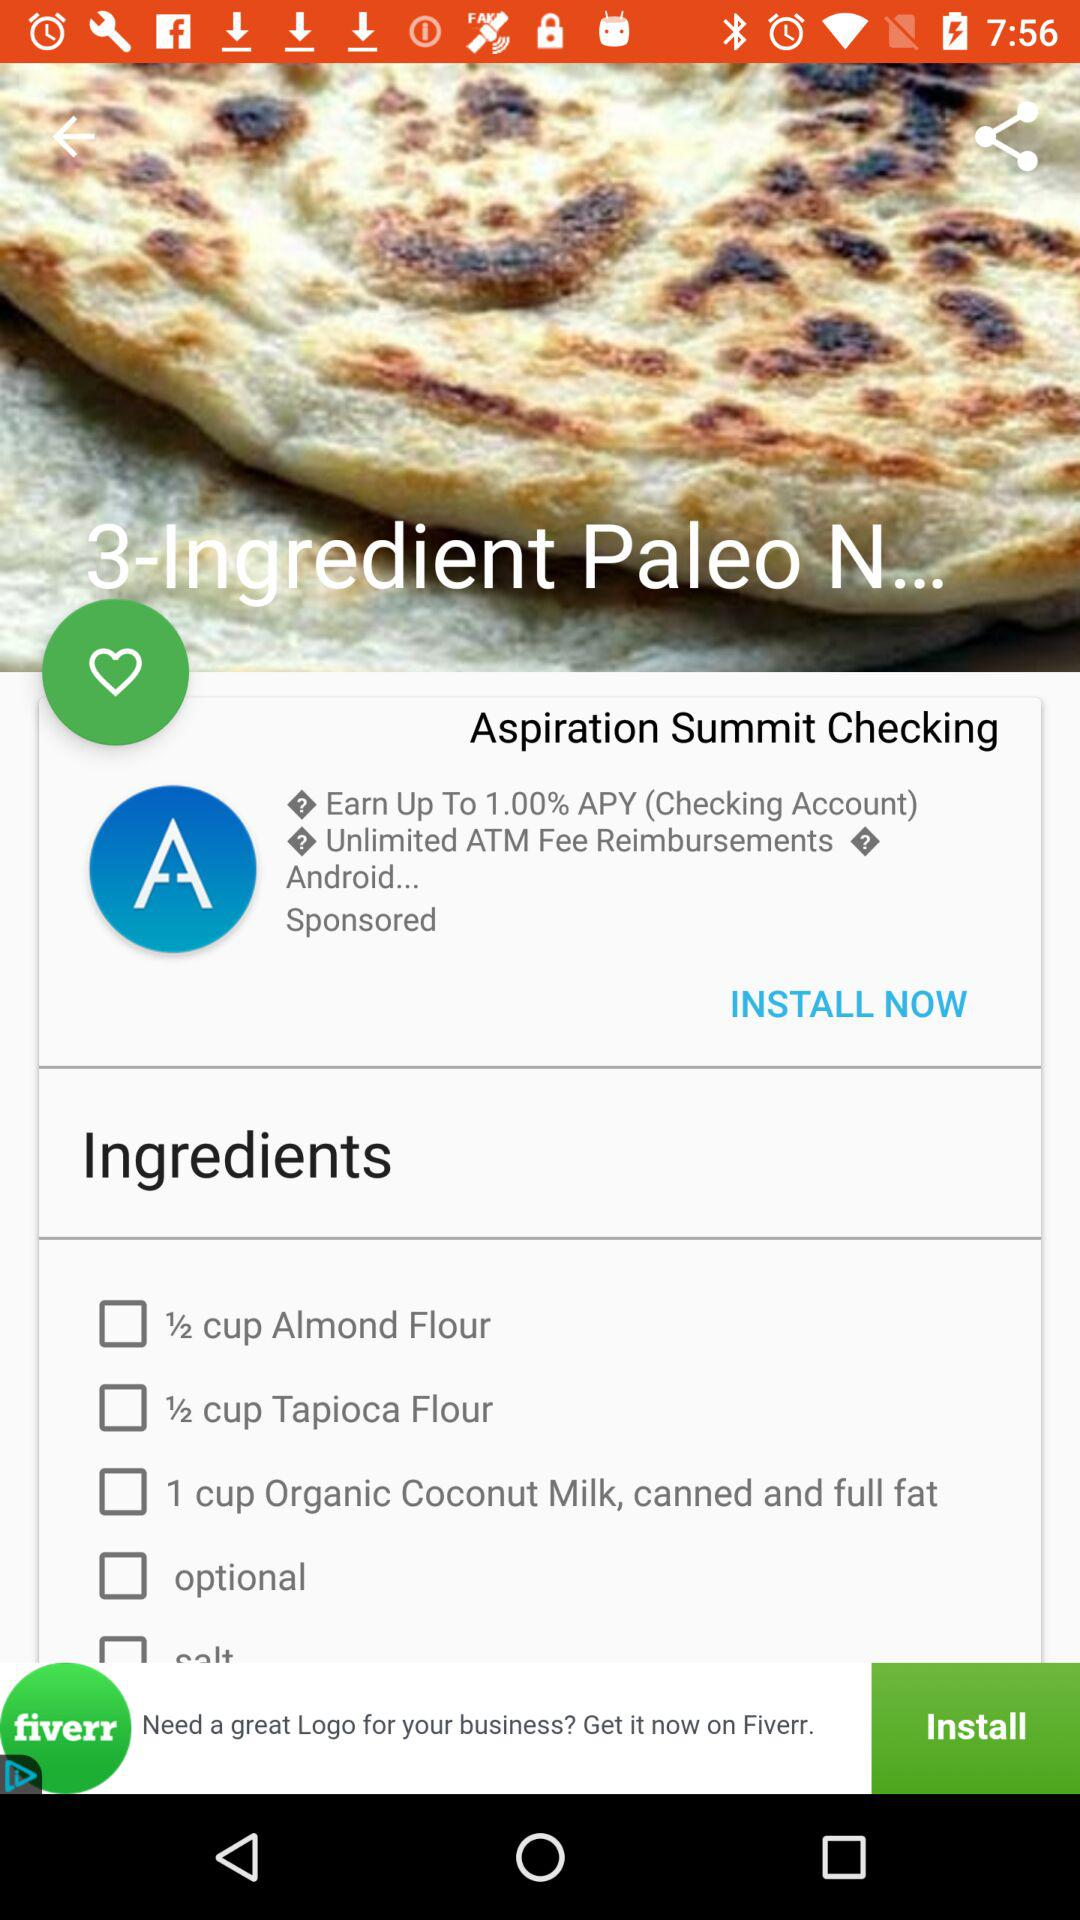What are the required ingredients in the list? The required ingredients are ½ cup almond flour, ½ cup tapioca flour and 1 cup organic coconut milk, canned and full-fat. 